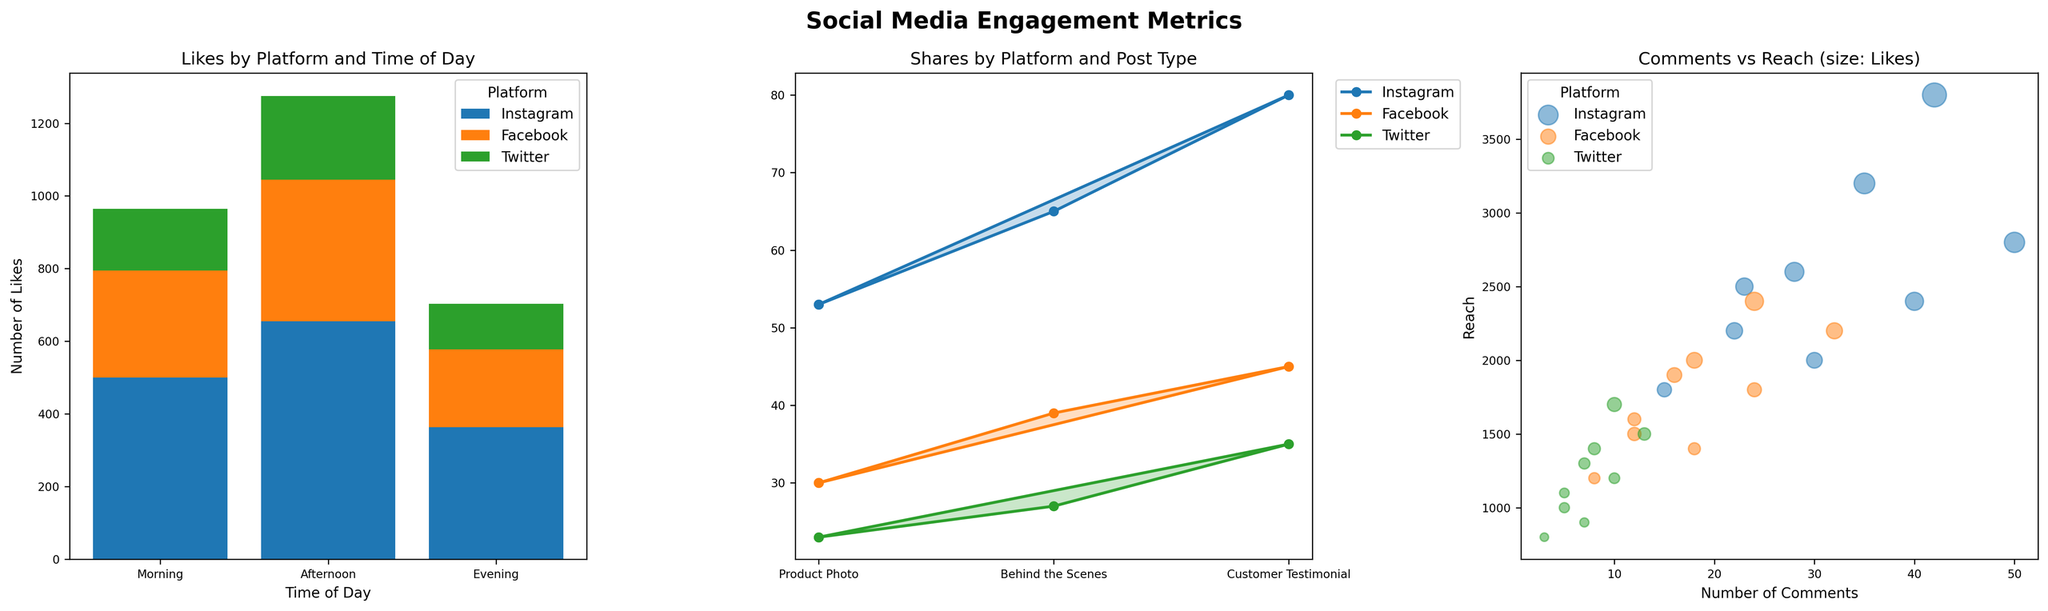what is the title of the stacked bar chart? The title of the stacked bar chart is located at the top of the subplot and reads 'Likes by Platform and Time of Day'.
Answer: Likes by Platform and Time of Day How many platforms are represented in the radar plot? The radar plot shows one line for each platform, and the legend at the top right indicates the number of platforms. There are 3 platforms: Instagram, Facebook, and Twitter.
Answer: 3 What does the size of the bubbles in the bubble plot represent? The size of the bubbles in the bubble plot is determined by the number of likes, as indicated by the title of the bubble plot 'Comments vs Reach (size: Likes)'.
Answer: Number of Likes Which platform has the most shares for the 'Product Photo' post type in the radar plot? By examining each line and fill in the radar plot, we can see which platform has the highest value on the 'Product Photo' axis. Instagram has the highest number of shares.
Answer: Instagram What is the total number of likes received in the morning across all platforms in the stacked bar chart? To find the total number of likes in the morning, sum the height of all bars corresponding to 'Morning': Instagram (145) + Facebook (85) + Twitter (50). This results in 145 + 85 + 50 = 280.
Answer: 280 Which time of day has the highest combined total reach for all platforms in the bubble plot? Add the reach for morning, afternoon, and evening across all platforms. Morning: (2500 + 1500 + 1000) = 5000; Afternoon: (3200 + 2000 + 1400) = 6600; Evening: (3800 + 2400 + 1700) = 7900. Evening has the highest combined total reach of 7900.
Answer: Evening Which post type has the least shares on Twitter according to the radar plot? By looking at the radar plot's axis for each post type and the corresponding shared values for the line representing Twitter, we can see that 'Behind the Scenes' has the least shares.
Answer: Behind the Scenes How does the number of comments change from morning to evening for Facebook? Reviewing the stacked bar chart for Facebook, the number of comments in the morning is 12, in the afternoon it is 18, and in the evening it is 24. The change from morning to evening is 24 - 12 = 12.
Answer: Increase by 12 Which platform appears to have the lowest overall engagement (likes, comments, shares) across all post types and times of day? Summing all metrics (likes, comments, shares) across post types and times for each platform, we can see that Twitter consistently has the lowest values compared to Instagram and Facebook.
Answer: Twitter 